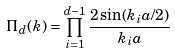Convert formula to latex. <formula><loc_0><loc_0><loc_500><loc_500>\Pi _ { d } ( k ) = \prod _ { i = 1 } ^ { d - 1 } \frac { 2 \sin ( k _ { i } a / 2 ) } { k _ { i } a }</formula> 